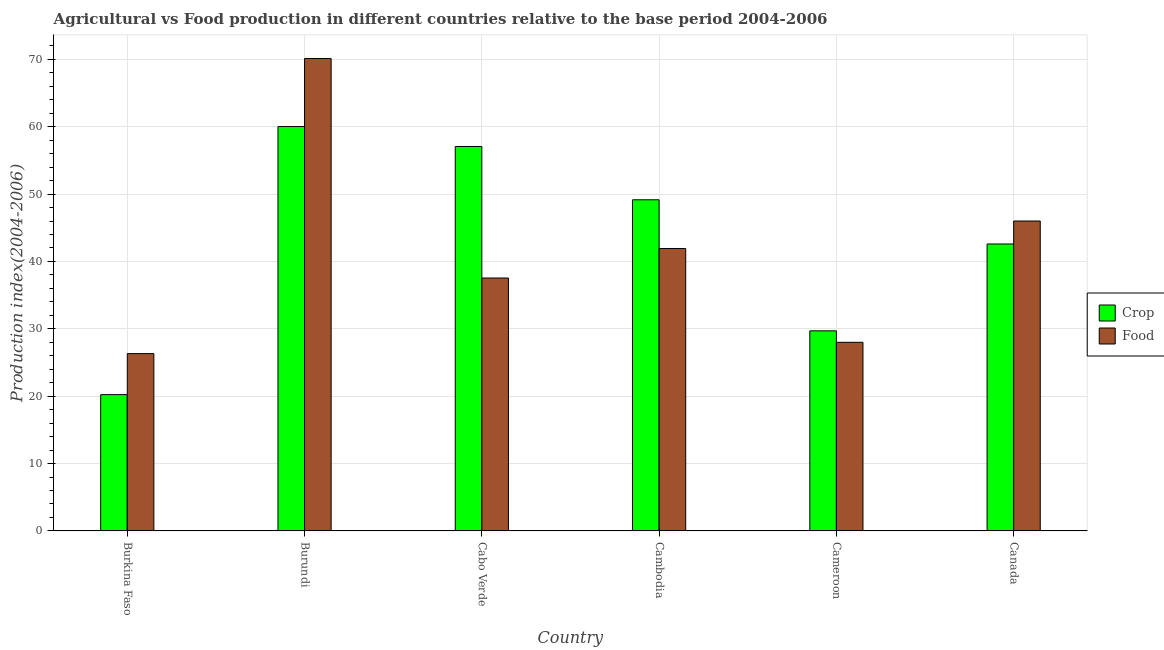How many different coloured bars are there?
Offer a very short reply. 2. How many groups of bars are there?
Give a very brief answer. 6. Are the number of bars per tick equal to the number of legend labels?
Provide a succinct answer. Yes. Are the number of bars on each tick of the X-axis equal?
Offer a terse response. Yes. How many bars are there on the 1st tick from the right?
Provide a succinct answer. 2. What is the label of the 1st group of bars from the left?
Give a very brief answer. Burkina Faso. What is the crop production index in Burundi?
Provide a short and direct response. 60.02. Across all countries, what is the maximum crop production index?
Keep it short and to the point. 60.02. Across all countries, what is the minimum crop production index?
Your answer should be compact. 20.23. In which country was the crop production index maximum?
Ensure brevity in your answer.  Burundi. In which country was the food production index minimum?
Ensure brevity in your answer.  Burkina Faso. What is the total crop production index in the graph?
Your response must be concise. 258.75. What is the difference between the crop production index in Cabo Verde and that in Cameroon?
Ensure brevity in your answer.  27.36. What is the difference between the food production index in Cabo Verde and the crop production index in Cameroon?
Your response must be concise. 7.84. What is the average food production index per country?
Provide a succinct answer. 41.65. What is the difference between the crop production index and food production index in Burkina Faso?
Your answer should be very brief. -6.09. In how many countries, is the crop production index greater than 4 ?
Offer a very short reply. 6. What is the ratio of the crop production index in Cambodia to that in Canada?
Offer a very short reply. 1.15. Is the difference between the food production index in Cabo Verde and Canada greater than the difference between the crop production index in Cabo Verde and Canada?
Your answer should be compact. No. What is the difference between the highest and the second highest food production index?
Provide a short and direct response. 24.12. What is the difference between the highest and the lowest food production index?
Provide a succinct answer. 43.8. In how many countries, is the crop production index greater than the average crop production index taken over all countries?
Provide a succinct answer. 3. Is the sum of the crop production index in Burkina Faso and Burundi greater than the maximum food production index across all countries?
Keep it short and to the point. Yes. What does the 2nd bar from the left in Canada represents?
Your answer should be compact. Food. What does the 2nd bar from the right in Burkina Faso represents?
Offer a terse response. Crop. How many bars are there?
Provide a succinct answer. 12. Are all the bars in the graph horizontal?
Offer a terse response. No. How many countries are there in the graph?
Keep it short and to the point. 6. What is the difference between two consecutive major ticks on the Y-axis?
Ensure brevity in your answer.  10. Does the graph contain grids?
Ensure brevity in your answer.  Yes. How are the legend labels stacked?
Your answer should be very brief. Vertical. What is the title of the graph?
Your response must be concise. Agricultural vs Food production in different countries relative to the base period 2004-2006. What is the label or title of the X-axis?
Your answer should be very brief. Country. What is the label or title of the Y-axis?
Your answer should be compact. Production index(2004-2006). What is the Production index(2004-2006) in Crop in Burkina Faso?
Offer a very short reply. 20.23. What is the Production index(2004-2006) of Food in Burkina Faso?
Keep it short and to the point. 26.32. What is the Production index(2004-2006) in Crop in Burundi?
Make the answer very short. 60.02. What is the Production index(2004-2006) in Food in Burundi?
Offer a very short reply. 70.12. What is the Production index(2004-2006) in Crop in Cabo Verde?
Make the answer very short. 57.06. What is the Production index(2004-2006) in Food in Cabo Verde?
Offer a terse response. 37.54. What is the Production index(2004-2006) of Crop in Cambodia?
Provide a succinct answer. 49.15. What is the Production index(2004-2006) in Food in Cambodia?
Provide a succinct answer. 41.92. What is the Production index(2004-2006) of Crop in Cameroon?
Your answer should be compact. 29.7. What is the Production index(2004-2006) of Crop in Canada?
Your response must be concise. 42.59. Across all countries, what is the maximum Production index(2004-2006) of Crop?
Offer a terse response. 60.02. Across all countries, what is the maximum Production index(2004-2006) in Food?
Keep it short and to the point. 70.12. Across all countries, what is the minimum Production index(2004-2006) in Crop?
Offer a very short reply. 20.23. Across all countries, what is the minimum Production index(2004-2006) of Food?
Provide a short and direct response. 26.32. What is the total Production index(2004-2006) of Crop in the graph?
Your response must be concise. 258.75. What is the total Production index(2004-2006) of Food in the graph?
Offer a very short reply. 249.9. What is the difference between the Production index(2004-2006) of Crop in Burkina Faso and that in Burundi?
Offer a very short reply. -39.79. What is the difference between the Production index(2004-2006) in Food in Burkina Faso and that in Burundi?
Your answer should be compact. -43.8. What is the difference between the Production index(2004-2006) of Crop in Burkina Faso and that in Cabo Verde?
Ensure brevity in your answer.  -36.83. What is the difference between the Production index(2004-2006) in Food in Burkina Faso and that in Cabo Verde?
Ensure brevity in your answer.  -11.22. What is the difference between the Production index(2004-2006) of Crop in Burkina Faso and that in Cambodia?
Your answer should be compact. -28.92. What is the difference between the Production index(2004-2006) of Food in Burkina Faso and that in Cambodia?
Provide a short and direct response. -15.6. What is the difference between the Production index(2004-2006) of Crop in Burkina Faso and that in Cameroon?
Offer a very short reply. -9.47. What is the difference between the Production index(2004-2006) in Food in Burkina Faso and that in Cameroon?
Provide a short and direct response. -1.68. What is the difference between the Production index(2004-2006) in Crop in Burkina Faso and that in Canada?
Ensure brevity in your answer.  -22.36. What is the difference between the Production index(2004-2006) in Food in Burkina Faso and that in Canada?
Your answer should be very brief. -19.68. What is the difference between the Production index(2004-2006) in Crop in Burundi and that in Cabo Verde?
Your answer should be compact. 2.96. What is the difference between the Production index(2004-2006) of Food in Burundi and that in Cabo Verde?
Offer a very short reply. 32.58. What is the difference between the Production index(2004-2006) in Crop in Burundi and that in Cambodia?
Your answer should be compact. 10.87. What is the difference between the Production index(2004-2006) in Food in Burundi and that in Cambodia?
Ensure brevity in your answer.  28.2. What is the difference between the Production index(2004-2006) in Crop in Burundi and that in Cameroon?
Keep it short and to the point. 30.32. What is the difference between the Production index(2004-2006) of Food in Burundi and that in Cameroon?
Offer a very short reply. 42.12. What is the difference between the Production index(2004-2006) in Crop in Burundi and that in Canada?
Provide a succinct answer. 17.43. What is the difference between the Production index(2004-2006) in Food in Burundi and that in Canada?
Give a very brief answer. 24.12. What is the difference between the Production index(2004-2006) in Crop in Cabo Verde and that in Cambodia?
Offer a very short reply. 7.91. What is the difference between the Production index(2004-2006) in Food in Cabo Verde and that in Cambodia?
Give a very brief answer. -4.38. What is the difference between the Production index(2004-2006) in Crop in Cabo Verde and that in Cameroon?
Your answer should be very brief. 27.36. What is the difference between the Production index(2004-2006) in Food in Cabo Verde and that in Cameroon?
Keep it short and to the point. 9.54. What is the difference between the Production index(2004-2006) in Crop in Cabo Verde and that in Canada?
Your answer should be compact. 14.47. What is the difference between the Production index(2004-2006) of Food in Cabo Verde and that in Canada?
Make the answer very short. -8.46. What is the difference between the Production index(2004-2006) in Crop in Cambodia and that in Cameroon?
Keep it short and to the point. 19.45. What is the difference between the Production index(2004-2006) in Food in Cambodia and that in Cameroon?
Offer a very short reply. 13.92. What is the difference between the Production index(2004-2006) of Crop in Cambodia and that in Canada?
Offer a very short reply. 6.56. What is the difference between the Production index(2004-2006) of Food in Cambodia and that in Canada?
Your answer should be very brief. -4.08. What is the difference between the Production index(2004-2006) of Crop in Cameroon and that in Canada?
Your answer should be very brief. -12.89. What is the difference between the Production index(2004-2006) of Crop in Burkina Faso and the Production index(2004-2006) of Food in Burundi?
Ensure brevity in your answer.  -49.89. What is the difference between the Production index(2004-2006) in Crop in Burkina Faso and the Production index(2004-2006) in Food in Cabo Verde?
Make the answer very short. -17.31. What is the difference between the Production index(2004-2006) of Crop in Burkina Faso and the Production index(2004-2006) of Food in Cambodia?
Make the answer very short. -21.69. What is the difference between the Production index(2004-2006) in Crop in Burkina Faso and the Production index(2004-2006) in Food in Cameroon?
Your answer should be very brief. -7.77. What is the difference between the Production index(2004-2006) in Crop in Burkina Faso and the Production index(2004-2006) in Food in Canada?
Your answer should be compact. -25.77. What is the difference between the Production index(2004-2006) in Crop in Burundi and the Production index(2004-2006) in Food in Cabo Verde?
Give a very brief answer. 22.48. What is the difference between the Production index(2004-2006) of Crop in Burundi and the Production index(2004-2006) of Food in Cameroon?
Offer a terse response. 32.02. What is the difference between the Production index(2004-2006) in Crop in Burundi and the Production index(2004-2006) in Food in Canada?
Your answer should be very brief. 14.02. What is the difference between the Production index(2004-2006) of Crop in Cabo Verde and the Production index(2004-2006) of Food in Cambodia?
Keep it short and to the point. 15.14. What is the difference between the Production index(2004-2006) in Crop in Cabo Verde and the Production index(2004-2006) in Food in Cameroon?
Give a very brief answer. 29.06. What is the difference between the Production index(2004-2006) of Crop in Cabo Verde and the Production index(2004-2006) of Food in Canada?
Offer a very short reply. 11.06. What is the difference between the Production index(2004-2006) of Crop in Cambodia and the Production index(2004-2006) of Food in Cameroon?
Give a very brief answer. 21.15. What is the difference between the Production index(2004-2006) of Crop in Cambodia and the Production index(2004-2006) of Food in Canada?
Offer a very short reply. 3.15. What is the difference between the Production index(2004-2006) of Crop in Cameroon and the Production index(2004-2006) of Food in Canada?
Provide a succinct answer. -16.3. What is the average Production index(2004-2006) in Crop per country?
Ensure brevity in your answer.  43.12. What is the average Production index(2004-2006) of Food per country?
Provide a succinct answer. 41.65. What is the difference between the Production index(2004-2006) in Crop and Production index(2004-2006) in Food in Burkina Faso?
Provide a succinct answer. -6.09. What is the difference between the Production index(2004-2006) of Crop and Production index(2004-2006) of Food in Burundi?
Provide a short and direct response. -10.1. What is the difference between the Production index(2004-2006) in Crop and Production index(2004-2006) in Food in Cabo Verde?
Offer a very short reply. 19.52. What is the difference between the Production index(2004-2006) in Crop and Production index(2004-2006) in Food in Cambodia?
Provide a short and direct response. 7.23. What is the difference between the Production index(2004-2006) of Crop and Production index(2004-2006) of Food in Canada?
Keep it short and to the point. -3.41. What is the ratio of the Production index(2004-2006) in Crop in Burkina Faso to that in Burundi?
Give a very brief answer. 0.34. What is the ratio of the Production index(2004-2006) in Food in Burkina Faso to that in Burundi?
Your answer should be very brief. 0.38. What is the ratio of the Production index(2004-2006) of Crop in Burkina Faso to that in Cabo Verde?
Offer a terse response. 0.35. What is the ratio of the Production index(2004-2006) in Food in Burkina Faso to that in Cabo Verde?
Give a very brief answer. 0.7. What is the ratio of the Production index(2004-2006) in Crop in Burkina Faso to that in Cambodia?
Provide a succinct answer. 0.41. What is the ratio of the Production index(2004-2006) of Food in Burkina Faso to that in Cambodia?
Your response must be concise. 0.63. What is the ratio of the Production index(2004-2006) in Crop in Burkina Faso to that in Cameroon?
Your response must be concise. 0.68. What is the ratio of the Production index(2004-2006) of Crop in Burkina Faso to that in Canada?
Keep it short and to the point. 0.47. What is the ratio of the Production index(2004-2006) of Food in Burkina Faso to that in Canada?
Provide a short and direct response. 0.57. What is the ratio of the Production index(2004-2006) of Crop in Burundi to that in Cabo Verde?
Make the answer very short. 1.05. What is the ratio of the Production index(2004-2006) in Food in Burundi to that in Cabo Verde?
Offer a terse response. 1.87. What is the ratio of the Production index(2004-2006) of Crop in Burundi to that in Cambodia?
Give a very brief answer. 1.22. What is the ratio of the Production index(2004-2006) of Food in Burundi to that in Cambodia?
Give a very brief answer. 1.67. What is the ratio of the Production index(2004-2006) in Crop in Burundi to that in Cameroon?
Offer a very short reply. 2.02. What is the ratio of the Production index(2004-2006) of Food in Burundi to that in Cameroon?
Make the answer very short. 2.5. What is the ratio of the Production index(2004-2006) of Crop in Burundi to that in Canada?
Your answer should be very brief. 1.41. What is the ratio of the Production index(2004-2006) of Food in Burundi to that in Canada?
Make the answer very short. 1.52. What is the ratio of the Production index(2004-2006) in Crop in Cabo Verde to that in Cambodia?
Give a very brief answer. 1.16. What is the ratio of the Production index(2004-2006) in Food in Cabo Verde to that in Cambodia?
Make the answer very short. 0.9. What is the ratio of the Production index(2004-2006) of Crop in Cabo Verde to that in Cameroon?
Offer a terse response. 1.92. What is the ratio of the Production index(2004-2006) in Food in Cabo Verde to that in Cameroon?
Provide a succinct answer. 1.34. What is the ratio of the Production index(2004-2006) in Crop in Cabo Verde to that in Canada?
Your response must be concise. 1.34. What is the ratio of the Production index(2004-2006) in Food in Cabo Verde to that in Canada?
Your response must be concise. 0.82. What is the ratio of the Production index(2004-2006) of Crop in Cambodia to that in Cameroon?
Make the answer very short. 1.65. What is the ratio of the Production index(2004-2006) of Food in Cambodia to that in Cameroon?
Give a very brief answer. 1.5. What is the ratio of the Production index(2004-2006) in Crop in Cambodia to that in Canada?
Your answer should be compact. 1.15. What is the ratio of the Production index(2004-2006) in Food in Cambodia to that in Canada?
Provide a succinct answer. 0.91. What is the ratio of the Production index(2004-2006) in Crop in Cameroon to that in Canada?
Make the answer very short. 0.7. What is the ratio of the Production index(2004-2006) of Food in Cameroon to that in Canada?
Make the answer very short. 0.61. What is the difference between the highest and the second highest Production index(2004-2006) of Crop?
Ensure brevity in your answer.  2.96. What is the difference between the highest and the second highest Production index(2004-2006) in Food?
Offer a very short reply. 24.12. What is the difference between the highest and the lowest Production index(2004-2006) in Crop?
Give a very brief answer. 39.79. What is the difference between the highest and the lowest Production index(2004-2006) of Food?
Keep it short and to the point. 43.8. 